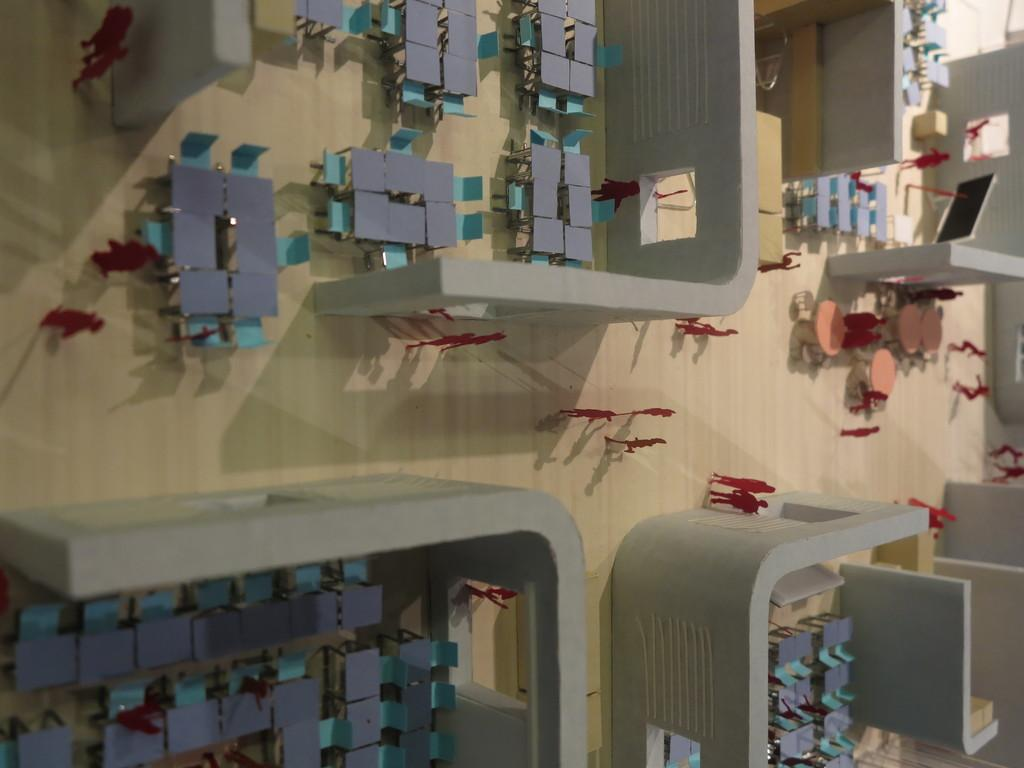What is the main object in the image? There is a table in the image. What is depicted on the table? The table has miniature art of a restaurant. What elements are included in the miniature art? The miniature art includes people and tables. What type of event is taking place at the restaurant in the image? There is no indication of an event taking place at the restaurant in the image; it only shows the miniature art of people and tables. What songs are being sung by the people in the miniature art? There is no information about songs being sung in the image, as it only depicts the miniature art of a restaurant with people and tables. 